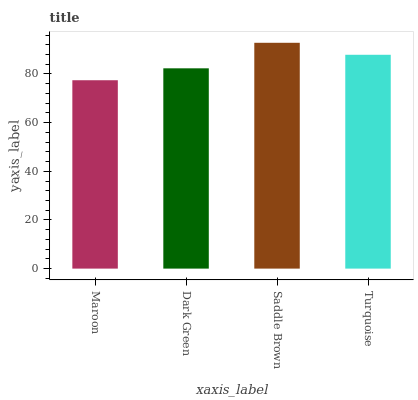Is Saddle Brown the maximum?
Answer yes or no. Yes. Is Dark Green the minimum?
Answer yes or no. No. Is Dark Green the maximum?
Answer yes or no. No. Is Dark Green greater than Maroon?
Answer yes or no. Yes. Is Maroon less than Dark Green?
Answer yes or no. Yes. Is Maroon greater than Dark Green?
Answer yes or no. No. Is Dark Green less than Maroon?
Answer yes or no. No. Is Turquoise the high median?
Answer yes or no. Yes. Is Dark Green the low median?
Answer yes or no. Yes. Is Maroon the high median?
Answer yes or no. No. Is Turquoise the low median?
Answer yes or no. No. 